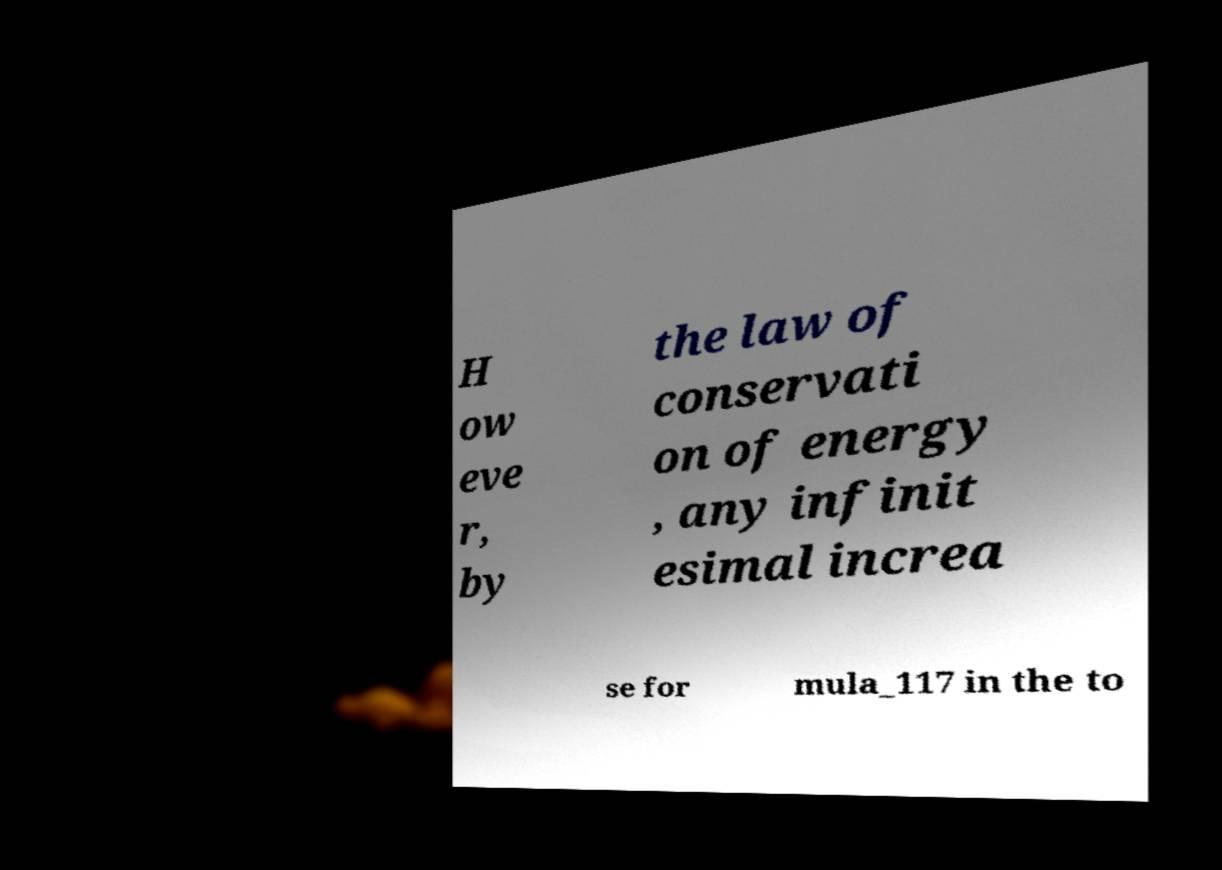Please read and relay the text visible in this image. What does it say? H ow eve r, by the law of conservati on of energy , any infinit esimal increa se for mula_117 in the to 